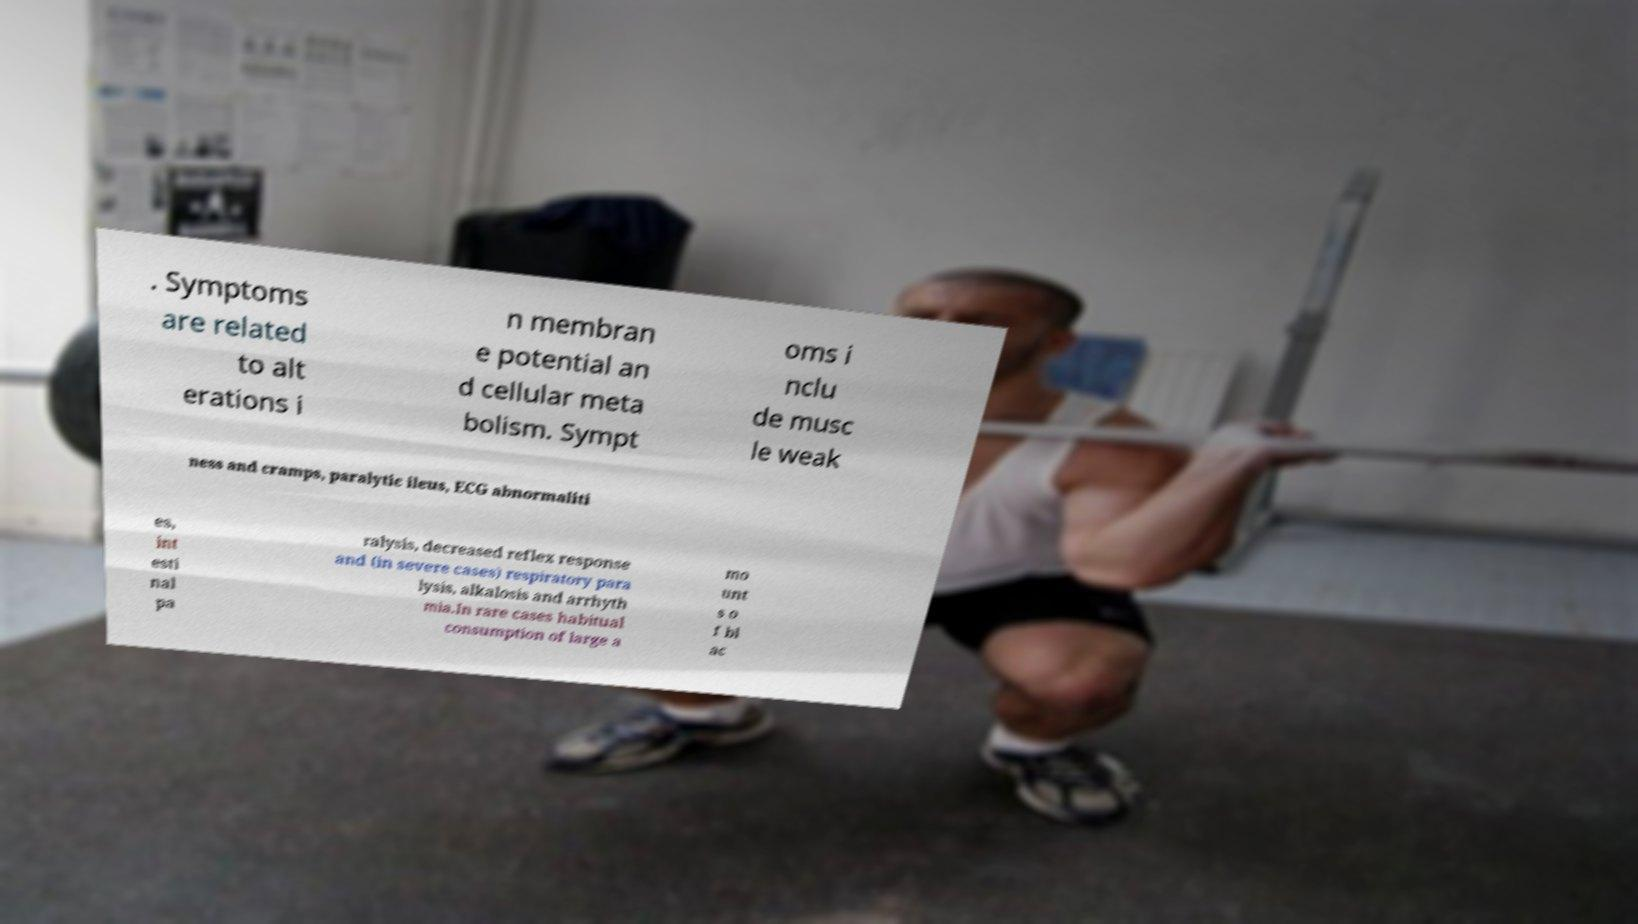I need the written content from this picture converted into text. Can you do that? . Symptoms are related to alt erations i n membran e potential an d cellular meta bolism. Sympt oms i nclu de musc le weak ness and cramps, paralytic ileus, ECG abnormaliti es, int esti nal pa ralysis, decreased reflex response and (in severe cases) respiratory para lysis, alkalosis and arrhyth mia.In rare cases habitual consumption of large a mo unt s o f bl ac 